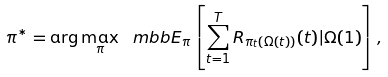<formula> <loc_0><loc_0><loc_500><loc_500>\pi ^ { * } = \arg \max _ { \pi } \ m b b E _ { \pi } \left [ \sum _ { t = 1 } ^ { T } R _ { \pi _ { t } ( \Omega ( t ) ) } ( t ) | \Omega ( 1 ) \right ] ,</formula> 